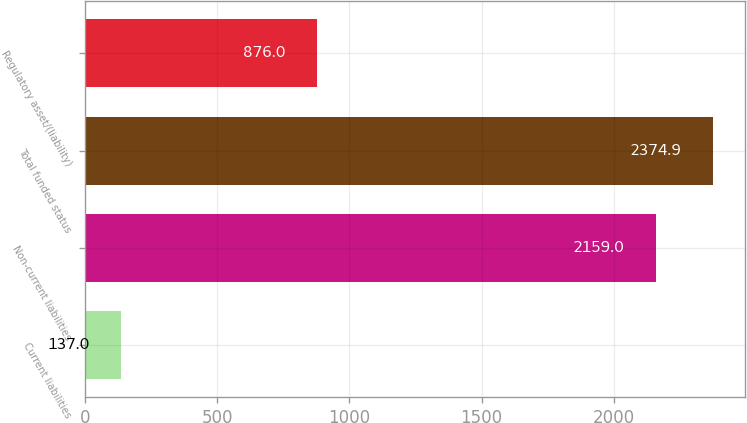Convert chart. <chart><loc_0><loc_0><loc_500><loc_500><bar_chart><fcel>Current liabilities<fcel>Non-current liabilities<fcel>Total funded status<fcel>Regulatory asset/(liability)<nl><fcel>137<fcel>2159<fcel>2374.9<fcel>876<nl></chart> 